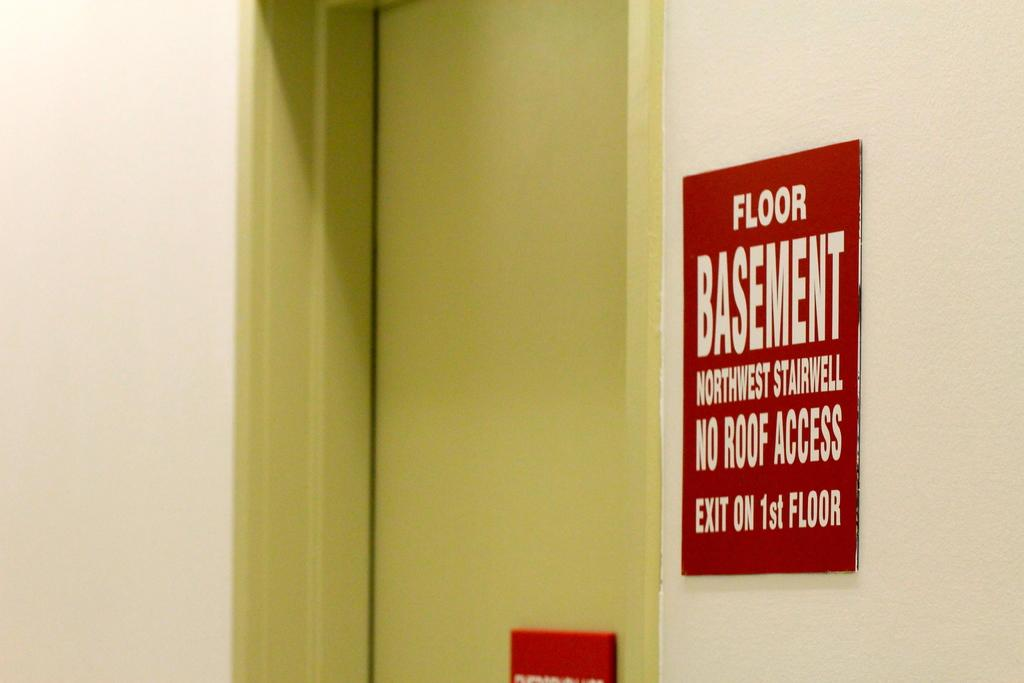Provide a one-sentence caption for the provided image. The sign indicating the basement's NW stairwell is red and white. 